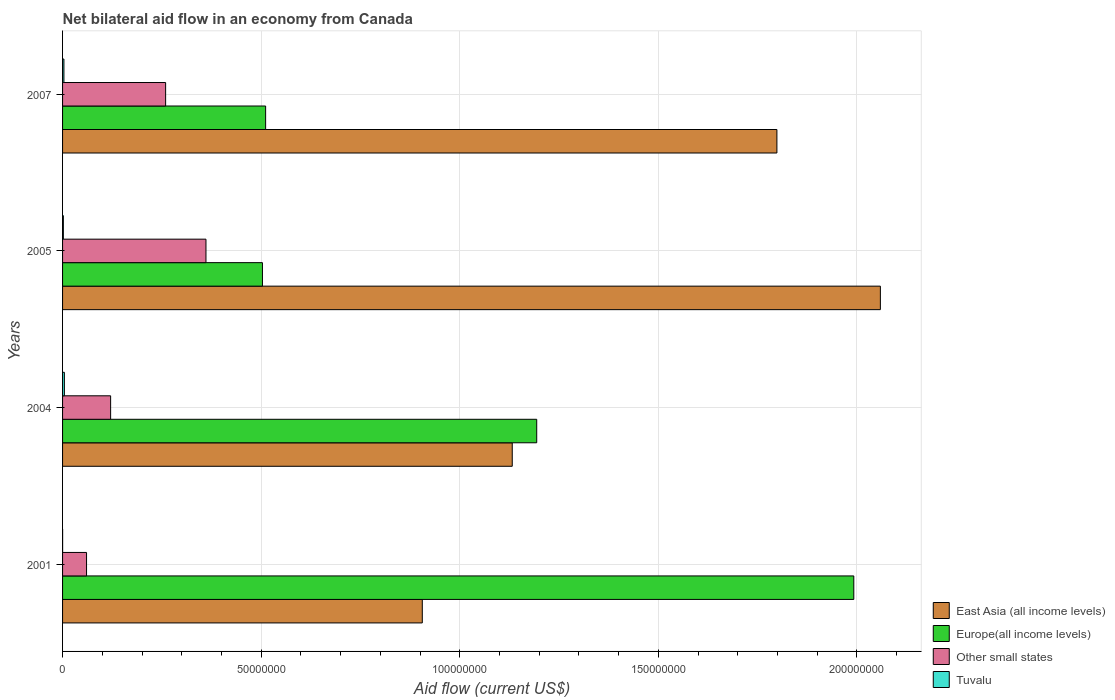How many different coloured bars are there?
Provide a succinct answer. 4. How many groups of bars are there?
Your answer should be very brief. 4. Are the number of bars per tick equal to the number of legend labels?
Make the answer very short. Yes. How many bars are there on the 1st tick from the top?
Offer a terse response. 4. How many bars are there on the 4th tick from the bottom?
Provide a succinct answer. 4. What is the label of the 2nd group of bars from the top?
Ensure brevity in your answer.  2005. What is the net bilateral aid flow in Other small states in 2007?
Ensure brevity in your answer.  2.60e+07. Across all years, what is the maximum net bilateral aid flow in Other small states?
Ensure brevity in your answer.  3.61e+07. Across all years, what is the minimum net bilateral aid flow in East Asia (all income levels)?
Offer a very short reply. 9.06e+07. What is the total net bilateral aid flow in East Asia (all income levels) in the graph?
Ensure brevity in your answer.  5.90e+08. What is the difference between the net bilateral aid flow in East Asia (all income levels) in 2004 and that in 2007?
Your answer should be very brief. -6.66e+07. What is the difference between the net bilateral aid flow in Other small states in 2004 and the net bilateral aid flow in Tuvalu in 2005?
Offer a very short reply. 1.19e+07. What is the average net bilateral aid flow in Other small states per year?
Ensure brevity in your answer.  2.00e+07. In the year 2004, what is the difference between the net bilateral aid flow in East Asia (all income levels) and net bilateral aid flow in Tuvalu?
Your answer should be compact. 1.13e+08. What is the ratio of the net bilateral aid flow in Other small states in 2004 to that in 2007?
Give a very brief answer. 0.47. What is the difference between the highest and the second highest net bilateral aid flow in East Asia (all income levels)?
Offer a terse response. 2.60e+07. What is the difference between the highest and the lowest net bilateral aid flow in Tuvalu?
Make the answer very short. 4.50e+05. Is the sum of the net bilateral aid flow in Other small states in 2001 and 2007 greater than the maximum net bilateral aid flow in Tuvalu across all years?
Offer a very short reply. Yes. Is it the case that in every year, the sum of the net bilateral aid flow in Tuvalu and net bilateral aid flow in Other small states is greater than the sum of net bilateral aid flow in Europe(all income levels) and net bilateral aid flow in East Asia (all income levels)?
Offer a very short reply. Yes. What does the 2nd bar from the top in 2007 represents?
Your response must be concise. Other small states. What does the 4th bar from the bottom in 2007 represents?
Offer a very short reply. Tuvalu. How many years are there in the graph?
Offer a very short reply. 4. Where does the legend appear in the graph?
Offer a very short reply. Bottom right. How are the legend labels stacked?
Offer a very short reply. Vertical. What is the title of the graph?
Make the answer very short. Net bilateral aid flow in an economy from Canada. What is the label or title of the X-axis?
Provide a short and direct response. Aid flow (current US$). What is the label or title of the Y-axis?
Provide a succinct answer. Years. What is the Aid flow (current US$) of East Asia (all income levels) in 2001?
Provide a succinct answer. 9.06e+07. What is the Aid flow (current US$) in Europe(all income levels) in 2001?
Provide a succinct answer. 1.99e+08. What is the Aid flow (current US$) of Other small states in 2001?
Keep it short and to the point. 6.04e+06. What is the Aid flow (current US$) in East Asia (all income levels) in 2004?
Make the answer very short. 1.13e+08. What is the Aid flow (current US$) in Europe(all income levels) in 2004?
Offer a very short reply. 1.19e+08. What is the Aid flow (current US$) of Other small states in 2004?
Offer a very short reply. 1.21e+07. What is the Aid flow (current US$) of East Asia (all income levels) in 2005?
Provide a succinct answer. 2.06e+08. What is the Aid flow (current US$) in Europe(all income levels) in 2005?
Offer a very short reply. 5.03e+07. What is the Aid flow (current US$) in Other small states in 2005?
Keep it short and to the point. 3.61e+07. What is the Aid flow (current US$) in East Asia (all income levels) in 2007?
Keep it short and to the point. 1.80e+08. What is the Aid flow (current US$) in Europe(all income levels) in 2007?
Your response must be concise. 5.11e+07. What is the Aid flow (current US$) in Other small states in 2007?
Give a very brief answer. 2.60e+07. What is the Aid flow (current US$) in Tuvalu in 2007?
Your answer should be compact. 3.40e+05. Across all years, what is the maximum Aid flow (current US$) of East Asia (all income levels)?
Make the answer very short. 2.06e+08. Across all years, what is the maximum Aid flow (current US$) of Europe(all income levels)?
Your answer should be compact. 1.99e+08. Across all years, what is the maximum Aid flow (current US$) of Other small states?
Provide a succinct answer. 3.61e+07. Across all years, what is the minimum Aid flow (current US$) in East Asia (all income levels)?
Your response must be concise. 9.06e+07. Across all years, what is the minimum Aid flow (current US$) in Europe(all income levels)?
Make the answer very short. 5.03e+07. Across all years, what is the minimum Aid flow (current US$) in Other small states?
Give a very brief answer. 6.04e+06. What is the total Aid flow (current US$) in East Asia (all income levels) in the graph?
Keep it short and to the point. 5.90e+08. What is the total Aid flow (current US$) of Europe(all income levels) in the graph?
Your answer should be compact. 4.20e+08. What is the total Aid flow (current US$) in Other small states in the graph?
Your answer should be very brief. 8.02e+07. What is the total Aid flow (current US$) in Tuvalu in the graph?
Provide a succinct answer. 1.01e+06. What is the difference between the Aid flow (current US$) of East Asia (all income levels) in 2001 and that in 2004?
Provide a short and direct response. -2.26e+07. What is the difference between the Aid flow (current US$) in Europe(all income levels) in 2001 and that in 2004?
Provide a short and direct response. 7.98e+07. What is the difference between the Aid flow (current US$) of Other small states in 2001 and that in 2004?
Make the answer very short. -6.06e+06. What is the difference between the Aid flow (current US$) in Tuvalu in 2001 and that in 2004?
Provide a short and direct response. -4.50e+05. What is the difference between the Aid flow (current US$) of East Asia (all income levels) in 2001 and that in 2005?
Keep it short and to the point. -1.15e+08. What is the difference between the Aid flow (current US$) in Europe(all income levels) in 2001 and that in 2005?
Offer a terse response. 1.49e+08. What is the difference between the Aid flow (current US$) in Other small states in 2001 and that in 2005?
Ensure brevity in your answer.  -3.01e+07. What is the difference between the Aid flow (current US$) of East Asia (all income levels) in 2001 and that in 2007?
Keep it short and to the point. -8.93e+07. What is the difference between the Aid flow (current US$) of Europe(all income levels) in 2001 and that in 2007?
Provide a short and direct response. 1.48e+08. What is the difference between the Aid flow (current US$) in Other small states in 2001 and that in 2007?
Give a very brief answer. -1.99e+07. What is the difference between the Aid flow (current US$) of Tuvalu in 2001 and that in 2007?
Your response must be concise. -3.30e+05. What is the difference between the Aid flow (current US$) in East Asia (all income levels) in 2004 and that in 2005?
Your response must be concise. -9.27e+07. What is the difference between the Aid flow (current US$) in Europe(all income levels) in 2004 and that in 2005?
Your response must be concise. 6.91e+07. What is the difference between the Aid flow (current US$) in Other small states in 2004 and that in 2005?
Your answer should be very brief. -2.40e+07. What is the difference between the Aid flow (current US$) of East Asia (all income levels) in 2004 and that in 2007?
Provide a short and direct response. -6.66e+07. What is the difference between the Aid flow (current US$) of Europe(all income levels) in 2004 and that in 2007?
Keep it short and to the point. 6.83e+07. What is the difference between the Aid flow (current US$) in Other small states in 2004 and that in 2007?
Ensure brevity in your answer.  -1.38e+07. What is the difference between the Aid flow (current US$) of Tuvalu in 2004 and that in 2007?
Offer a very short reply. 1.20e+05. What is the difference between the Aid flow (current US$) of East Asia (all income levels) in 2005 and that in 2007?
Your answer should be very brief. 2.60e+07. What is the difference between the Aid flow (current US$) of Europe(all income levels) in 2005 and that in 2007?
Your answer should be very brief. -8.00e+05. What is the difference between the Aid flow (current US$) of Other small states in 2005 and that in 2007?
Your answer should be compact. 1.02e+07. What is the difference between the Aid flow (current US$) of East Asia (all income levels) in 2001 and the Aid flow (current US$) of Europe(all income levels) in 2004?
Provide a succinct answer. -2.88e+07. What is the difference between the Aid flow (current US$) of East Asia (all income levels) in 2001 and the Aid flow (current US$) of Other small states in 2004?
Your answer should be very brief. 7.85e+07. What is the difference between the Aid flow (current US$) of East Asia (all income levels) in 2001 and the Aid flow (current US$) of Tuvalu in 2004?
Make the answer very short. 9.01e+07. What is the difference between the Aid flow (current US$) of Europe(all income levels) in 2001 and the Aid flow (current US$) of Other small states in 2004?
Keep it short and to the point. 1.87e+08. What is the difference between the Aid flow (current US$) in Europe(all income levels) in 2001 and the Aid flow (current US$) in Tuvalu in 2004?
Offer a very short reply. 1.99e+08. What is the difference between the Aid flow (current US$) of Other small states in 2001 and the Aid flow (current US$) of Tuvalu in 2004?
Keep it short and to the point. 5.58e+06. What is the difference between the Aid flow (current US$) of East Asia (all income levels) in 2001 and the Aid flow (current US$) of Europe(all income levels) in 2005?
Provide a short and direct response. 4.02e+07. What is the difference between the Aid flow (current US$) in East Asia (all income levels) in 2001 and the Aid flow (current US$) in Other small states in 2005?
Your answer should be very brief. 5.45e+07. What is the difference between the Aid flow (current US$) in East Asia (all income levels) in 2001 and the Aid flow (current US$) in Tuvalu in 2005?
Your response must be concise. 9.04e+07. What is the difference between the Aid flow (current US$) of Europe(all income levels) in 2001 and the Aid flow (current US$) of Other small states in 2005?
Give a very brief answer. 1.63e+08. What is the difference between the Aid flow (current US$) in Europe(all income levels) in 2001 and the Aid flow (current US$) in Tuvalu in 2005?
Your answer should be very brief. 1.99e+08. What is the difference between the Aid flow (current US$) in Other small states in 2001 and the Aid flow (current US$) in Tuvalu in 2005?
Your response must be concise. 5.84e+06. What is the difference between the Aid flow (current US$) in East Asia (all income levels) in 2001 and the Aid flow (current US$) in Europe(all income levels) in 2007?
Your answer should be compact. 3.94e+07. What is the difference between the Aid flow (current US$) in East Asia (all income levels) in 2001 and the Aid flow (current US$) in Other small states in 2007?
Your answer should be compact. 6.46e+07. What is the difference between the Aid flow (current US$) of East Asia (all income levels) in 2001 and the Aid flow (current US$) of Tuvalu in 2007?
Give a very brief answer. 9.02e+07. What is the difference between the Aid flow (current US$) of Europe(all income levels) in 2001 and the Aid flow (current US$) of Other small states in 2007?
Give a very brief answer. 1.73e+08. What is the difference between the Aid flow (current US$) of Europe(all income levels) in 2001 and the Aid flow (current US$) of Tuvalu in 2007?
Give a very brief answer. 1.99e+08. What is the difference between the Aid flow (current US$) of Other small states in 2001 and the Aid flow (current US$) of Tuvalu in 2007?
Provide a succinct answer. 5.70e+06. What is the difference between the Aid flow (current US$) in East Asia (all income levels) in 2004 and the Aid flow (current US$) in Europe(all income levels) in 2005?
Your answer should be compact. 6.29e+07. What is the difference between the Aid flow (current US$) of East Asia (all income levels) in 2004 and the Aid flow (current US$) of Other small states in 2005?
Make the answer very short. 7.71e+07. What is the difference between the Aid flow (current US$) in East Asia (all income levels) in 2004 and the Aid flow (current US$) in Tuvalu in 2005?
Ensure brevity in your answer.  1.13e+08. What is the difference between the Aid flow (current US$) in Europe(all income levels) in 2004 and the Aid flow (current US$) in Other small states in 2005?
Offer a very short reply. 8.33e+07. What is the difference between the Aid flow (current US$) of Europe(all income levels) in 2004 and the Aid flow (current US$) of Tuvalu in 2005?
Give a very brief answer. 1.19e+08. What is the difference between the Aid flow (current US$) of Other small states in 2004 and the Aid flow (current US$) of Tuvalu in 2005?
Your answer should be compact. 1.19e+07. What is the difference between the Aid flow (current US$) of East Asia (all income levels) in 2004 and the Aid flow (current US$) of Europe(all income levels) in 2007?
Give a very brief answer. 6.21e+07. What is the difference between the Aid flow (current US$) of East Asia (all income levels) in 2004 and the Aid flow (current US$) of Other small states in 2007?
Offer a terse response. 8.73e+07. What is the difference between the Aid flow (current US$) in East Asia (all income levels) in 2004 and the Aid flow (current US$) in Tuvalu in 2007?
Keep it short and to the point. 1.13e+08. What is the difference between the Aid flow (current US$) of Europe(all income levels) in 2004 and the Aid flow (current US$) of Other small states in 2007?
Provide a succinct answer. 9.34e+07. What is the difference between the Aid flow (current US$) in Europe(all income levels) in 2004 and the Aid flow (current US$) in Tuvalu in 2007?
Keep it short and to the point. 1.19e+08. What is the difference between the Aid flow (current US$) in Other small states in 2004 and the Aid flow (current US$) in Tuvalu in 2007?
Provide a short and direct response. 1.18e+07. What is the difference between the Aid flow (current US$) in East Asia (all income levels) in 2005 and the Aid flow (current US$) in Europe(all income levels) in 2007?
Provide a succinct answer. 1.55e+08. What is the difference between the Aid flow (current US$) of East Asia (all income levels) in 2005 and the Aid flow (current US$) of Other small states in 2007?
Provide a succinct answer. 1.80e+08. What is the difference between the Aid flow (current US$) in East Asia (all income levels) in 2005 and the Aid flow (current US$) in Tuvalu in 2007?
Provide a succinct answer. 2.06e+08. What is the difference between the Aid flow (current US$) of Europe(all income levels) in 2005 and the Aid flow (current US$) of Other small states in 2007?
Give a very brief answer. 2.44e+07. What is the difference between the Aid flow (current US$) of Europe(all income levels) in 2005 and the Aid flow (current US$) of Tuvalu in 2007?
Ensure brevity in your answer.  5.00e+07. What is the difference between the Aid flow (current US$) in Other small states in 2005 and the Aid flow (current US$) in Tuvalu in 2007?
Your answer should be compact. 3.58e+07. What is the average Aid flow (current US$) in East Asia (all income levels) per year?
Make the answer very short. 1.47e+08. What is the average Aid flow (current US$) in Europe(all income levels) per year?
Give a very brief answer. 1.05e+08. What is the average Aid flow (current US$) of Other small states per year?
Provide a short and direct response. 2.00e+07. What is the average Aid flow (current US$) in Tuvalu per year?
Make the answer very short. 2.52e+05. In the year 2001, what is the difference between the Aid flow (current US$) of East Asia (all income levels) and Aid flow (current US$) of Europe(all income levels)?
Make the answer very short. -1.09e+08. In the year 2001, what is the difference between the Aid flow (current US$) in East Asia (all income levels) and Aid flow (current US$) in Other small states?
Make the answer very short. 8.45e+07. In the year 2001, what is the difference between the Aid flow (current US$) of East Asia (all income levels) and Aid flow (current US$) of Tuvalu?
Keep it short and to the point. 9.06e+07. In the year 2001, what is the difference between the Aid flow (current US$) of Europe(all income levels) and Aid flow (current US$) of Other small states?
Your answer should be compact. 1.93e+08. In the year 2001, what is the difference between the Aid flow (current US$) of Europe(all income levels) and Aid flow (current US$) of Tuvalu?
Offer a very short reply. 1.99e+08. In the year 2001, what is the difference between the Aid flow (current US$) of Other small states and Aid flow (current US$) of Tuvalu?
Your response must be concise. 6.03e+06. In the year 2004, what is the difference between the Aid flow (current US$) in East Asia (all income levels) and Aid flow (current US$) in Europe(all income levels)?
Keep it short and to the point. -6.16e+06. In the year 2004, what is the difference between the Aid flow (current US$) in East Asia (all income levels) and Aid flow (current US$) in Other small states?
Ensure brevity in your answer.  1.01e+08. In the year 2004, what is the difference between the Aid flow (current US$) of East Asia (all income levels) and Aid flow (current US$) of Tuvalu?
Your answer should be very brief. 1.13e+08. In the year 2004, what is the difference between the Aid flow (current US$) of Europe(all income levels) and Aid flow (current US$) of Other small states?
Ensure brevity in your answer.  1.07e+08. In the year 2004, what is the difference between the Aid flow (current US$) of Europe(all income levels) and Aid flow (current US$) of Tuvalu?
Your response must be concise. 1.19e+08. In the year 2004, what is the difference between the Aid flow (current US$) of Other small states and Aid flow (current US$) of Tuvalu?
Provide a short and direct response. 1.16e+07. In the year 2005, what is the difference between the Aid flow (current US$) in East Asia (all income levels) and Aid flow (current US$) in Europe(all income levels)?
Your answer should be compact. 1.56e+08. In the year 2005, what is the difference between the Aid flow (current US$) in East Asia (all income levels) and Aid flow (current US$) in Other small states?
Offer a terse response. 1.70e+08. In the year 2005, what is the difference between the Aid flow (current US$) in East Asia (all income levels) and Aid flow (current US$) in Tuvalu?
Offer a terse response. 2.06e+08. In the year 2005, what is the difference between the Aid flow (current US$) in Europe(all income levels) and Aid flow (current US$) in Other small states?
Provide a succinct answer. 1.42e+07. In the year 2005, what is the difference between the Aid flow (current US$) of Europe(all income levels) and Aid flow (current US$) of Tuvalu?
Provide a succinct answer. 5.01e+07. In the year 2005, what is the difference between the Aid flow (current US$) of Other small states and Aid flow (current US$) of Tuvalu?
Offer a very short reply. 3.59e+07. In the year 2007, what is the difference between the Aid flow (current US$) of East Asia (all income levels) and Aid flow (current US$) of Europe(all income levels)?
Keep it short and to the point. 1.29e+08. In the year 2007, what is the difference between the Aid flow (current US$) of East Asia (all income levels) and Aid flow (current US$) of Other small states?
Provide a short and direct response. 1.54e+08. In the year 2007, what is the difference between the Aid flow (current US$) of East Asia (all income levels) and Aid flow (current US$) of Tuvalu?
Give a very brief answer. 1.80e+08. In the year 2007, what is the difference between the Aid flow (current US$) in Europe(all income levels) and Aid flow (current US$) in Other small states?
Give a very brief answer. 2.52e+07. In the year 2007, what is the difference between the Aid flow (current US$) in Europe(all income levels) and Aid flow (current US$) in Tuvalu?
Your answer should be very brief. 5.08e+07. In the year 2007, what is the difference between the Aid flow (current US$) of Other small states and Aid flow (current US$) of Tuvalu?
Offer a very short reply. 2.56e+07. What is the ratio of the Aid flow (current US$) in East Asia (all income levels) in 2001 to that in 2004?
Ensure brevity in your answer.  0.8. What is the ratio of the Aid flow (current US$) of Europe(all income levels) in 2001 to that in 2004?
Your answer should be very brief. 1.67. What is the ratio of the Aid flow (current US$) of Other small states in 2001 to that in 2004?
Make the answer very short. 0.5. What is the ratio of the Aid flow (current US$) of Tuvalu in 2001 to that in 2004?
Make the answer very short. 0.02. What is the ratio of the Aid flow (current US$) of East Asia (all income levels) in 2001 to that in 2005?
Your answer should be compact. 0.44. What is the ratio of the Aid flow (current US$) in Europe(all income levels) in 2001 to that in 2005?
Offer a terse response. 3.96. What is the ratio of the Aid flow (current US$) of Other small states in 2001 to that in 2005?
Provide a short and direct response. 0.17. What is the ratio of the Aid flow (current US$) of East Asia (all income levels) in 2001 to that in 2007?
Give a very brief answer. 0.5. What is the ratio of the Aid flow (current US$) of Europe(all income levels) in 2001 to that in 2007?
Keep it short and to the point. 3.9. What is the ratio of the Aid flow (current US$) of Other small states in 2001 to that in 2007?
Offer a very short reply. 0.23. What is the ratio of the Aid flow (current US$) in Tuvalu in 2001 to that in 2007?
Offer a very short reply. 0.03. What is the ratio of the Aid flow (current US$) in East Asia (all income levels) in 2004 to that in 2005?
Keep it short and to the point. 0.55. What is the ratio of the Aid flow (current US$) in Europe(all income levels) in 2004 to that in 2005?
Keep it short and to the point. 2.37. What is the ratio of the Aid flow (current US$) in Other small states in 2004 to that in 2005?
Your answer should be compact. 0.34. What is the ratio of the Aid flow (current US$) in East Asia (all income levels) in 2004 to that in 2007?
Your answer should be very brief. 0.63. What is the ratio of the Aid flow (current US$) of Europe(all income levels) in 2004 to that in 2007?
Ensure brevity in your answer.  2.33. What is the ratio of the Aid flow (current US$) of Other small states in 2004 to that in 2007?
Your answer should be very brief. 0.47. What is the ratio of the Aid flow (current US$) of Tuvalu in 2004 to that in 2007?
Offer a terse response. 1.35. What is the ratio of the Aid flow (current US$) of East Asia (all income levels) in 2005 to that in 2007?
Offer a very short reply. 1.14. What is the ratio of the Aid flow (current US$) of Europe(all income levels) in 2005 to that in 2007?
Make the answer very short. 0.98. What is the ratio of the Aid flow (current US$) of Other small states in 2005 to that in 2007?
Offer a very short reply. 1.39. What is the ratio of the Aid flow (current US$) in Tuvalu in 2005 to that in 2007?
Make the answer very short. 0.59. What is the difference between the highest and the second highest Aid flow (current US$) in East Asia (all income levels)?
Your answer should be very brief. 2.60e+07. What is the difference between the highest and the second highest Aid flow (current US$) in Europe(all income levels)?
Make the answer very short. 7.98e+07. What is the difference between the highest and the second highest Aid flow (current US$) of Other small states?
Offer a very short reply. 1.02e+07. What is the difference between the highest and the lowest Aid flow (current US$) of East Asia (all income levels)?
Give a very brief answer. 1.15e+08. What is the difference between the highest and the lowest Aid flow (current US$) of Europe(all income levels)?
Make the answer very short. 1.49e+08. What is the difference between the highest and the lowest Aid flow (current US$) in Other small states?
Ensure brevity in your answer.  3.01e+07. 